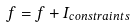Convert formula to latex. <formula><loc_0><loc_0><loc_500><loc_500>f = f + I _ { c o n s t r a i n t s }</formula> 